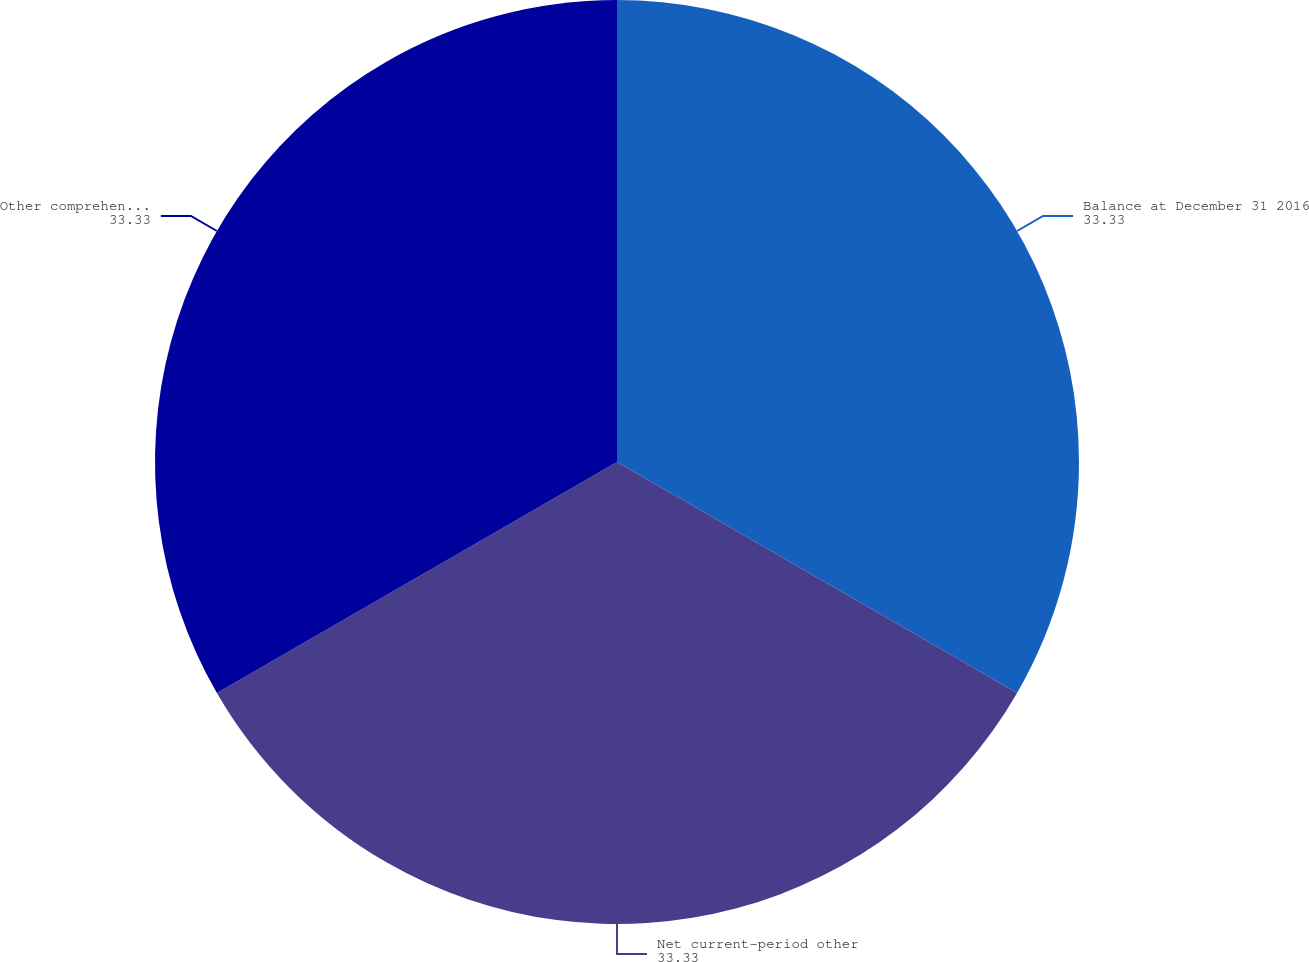Convert chart to OTSL. <chart><loc_0><loc_0><loc_500><loc_500><pie_chart><fcel>Balance at December 31 2016<fcel>Net current-period other<fcel>Other comprehensive income<nl><fcel>33.33%<fcel>33.33%<fcel>33.33%<nl></chart> 